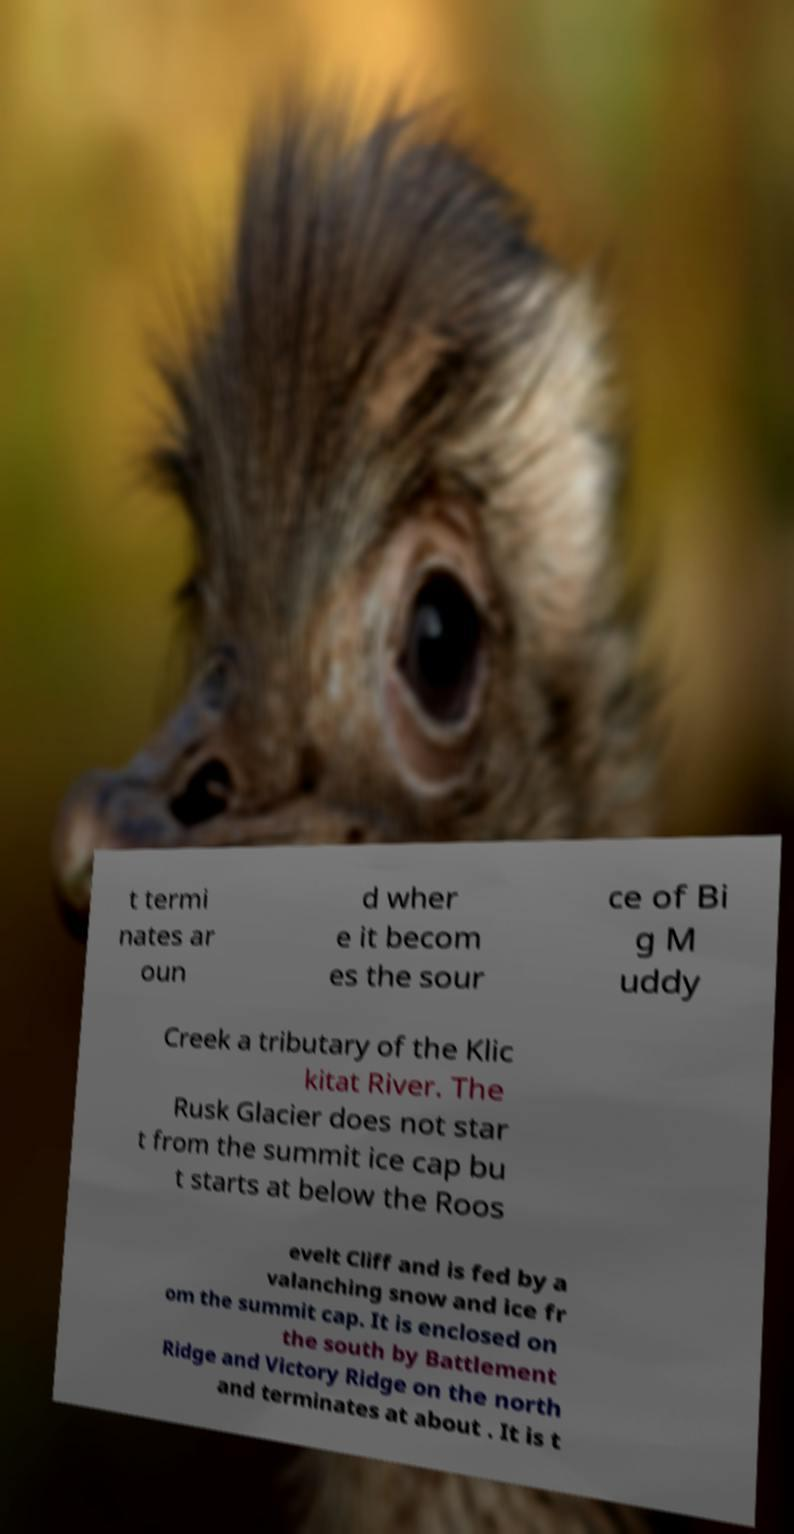There's text embedded in this image that I need extracted. Can you transcribe it verbatim? t termi nates ar oun d wher e it becom es the sour ce of Bi g M uddy Creek a tributary of the Klic kitat River. The Rusk Glacier does not star t from the summit ice cap bu t starts at below the Roos evelt Cliff and is fed by a valanching snow and ice fr om the summit cap. It is enclosed on the south by Battlement Ridge and Victory Ridge on the north and terminates at about . It is t 